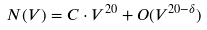Convert formula to latex. <formula><loc_0><loc_0><loc_500><loc_500>N ( V ) = C \cdot V ^ { 2 0 } + O ( V ^ { 2 0 - \delta } )</formula> 